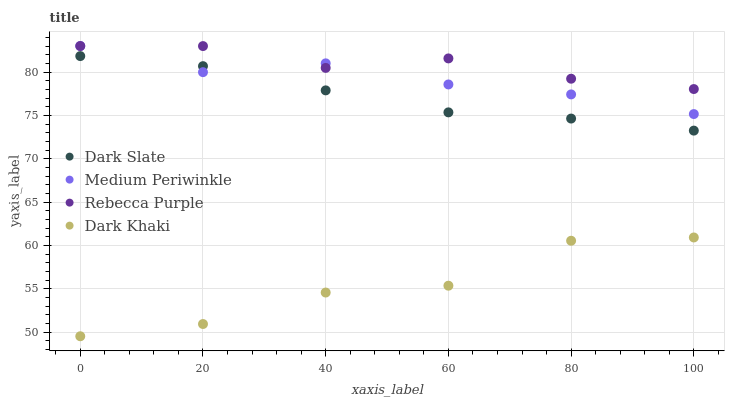Does Dark Khaki have the minimum area under the curve?
Answer yes or no. Yes. Does Rebecca Purple have the maximum area under the curve?
Answer yes or no. Yes. Does Dark Slate have the minimum area under the curve?
Answer yes or no. No. Does Dark Slate have the maximum area under the curve?
Answer yes or no. No. Is Dark Slate the smoothest?
Answer yes or no. Yes. Is Dark Khaki the roughest?
Answer yes or no. Yes. Is Medium Periwinkle the smoothest?
Answer yes or no. No. Is Medium Periwinkle the roughest?
Answer yes or no. No. Does Dark Khaki have the lowest value?
Answer yes or no. Yes. Does Dark Slate have the lowest value?
Answer yes or no. No. Does Rebecca Purple have the highest value?
Answer yes or no. Yes. Does Dark Slate have the highest value?
Answer yes or no. No. Is Dark Khaki less than Dark Slate?
Answer yes or no. Yes. Is Rebecca Purple greater than Dark Slate?
Answer yes or no. Yes. Does Rebecca Purple intersect Medium Periwinkle?
Answer yes or no. Yes. Is Rebecca Purple less than Medium Periwinkle?
Answer yes or no. No. Is Rebecca Purple greater than Medium Periwinkle?
Answer yes or no. No. Does Dark Khaki intersect Dark Slate?
Answer yes or no. No. 